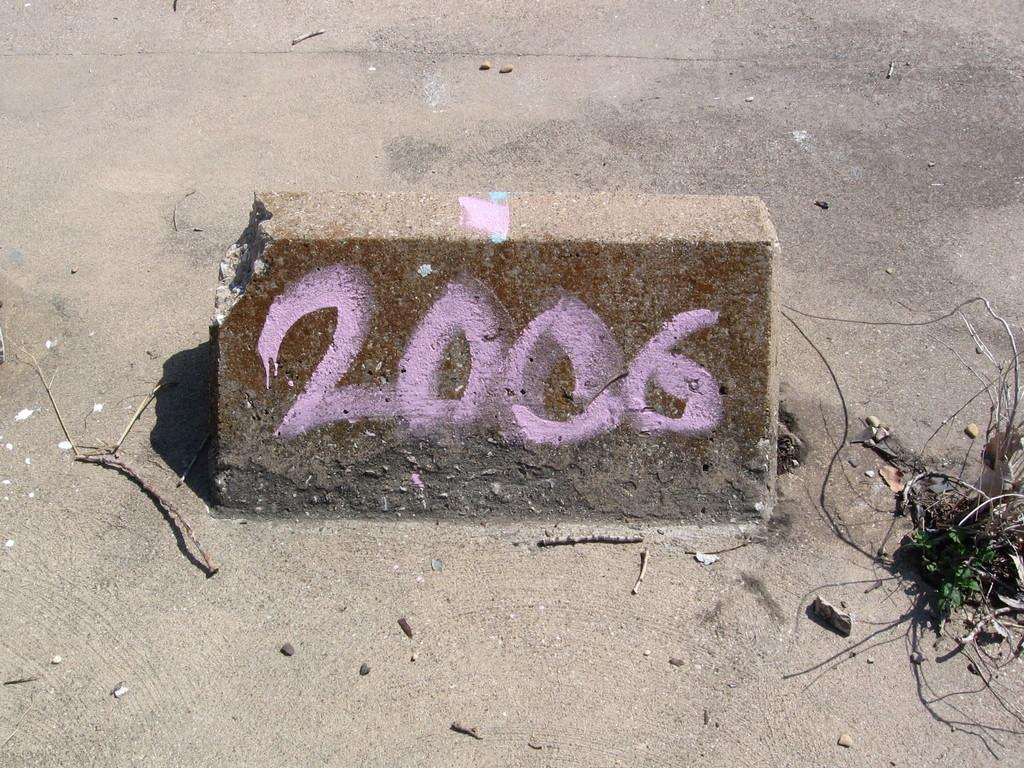What is the main subject of the image? The main subject of the image is text on a stone in the center of the image. Can you describe the text on the stone? Unfortunately, the specific text on the stone cannot be determined from the image. What else can be seen in the background of the image? There are twigs on the road in the background of the image. What type of quiver is visible on the stone in the image? There is no quiver present on the stone in the image. How does the memory of the event relate to the text on the stone? The image does not provide any information about an event or memory, so it is not possible to determine how the text on the stone relates to a memory. 